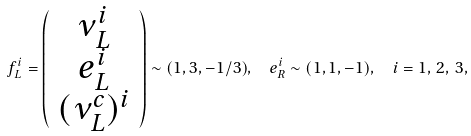<formula> <loc_0><loc_0><loc_500><loc_500>f ^ { i } _ { L } = \left ( \begin{array} { c c c } \nu ^ { i } _ { L } \\ e ^ { i } _ { L } \\ ( \nu ^ { c } _ { L } ) ^ { i } \end{array} \right ) \sim ( 1 , 3 , - 1 / 3 ) , \ \ e ^ { i } _ { R } \sim ( 1 , 1 , - 1 ) , \ \ i = 1 , \, 2 , \, 3 ,</formula> 